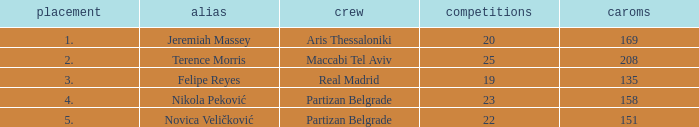How many Rebounds did Novica Veličković get in less than 22 Games? None. 